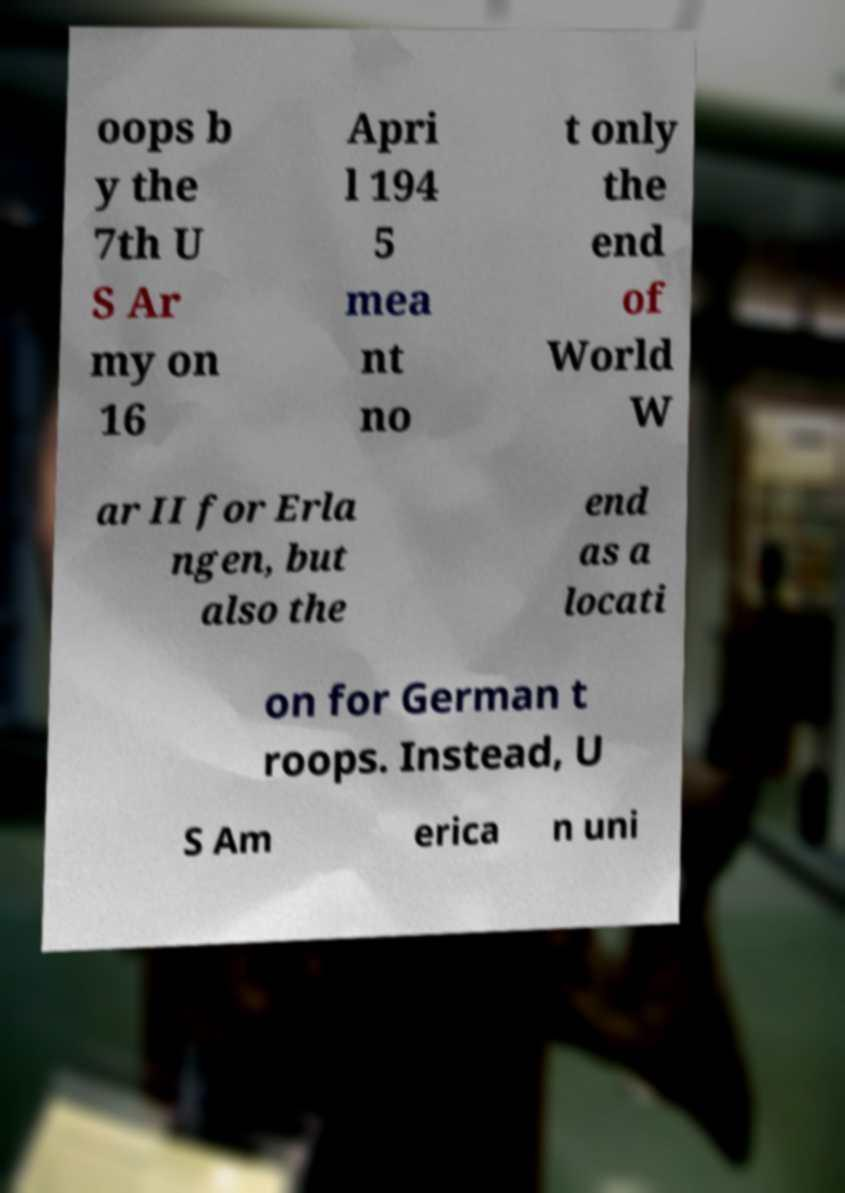Can you read and provide the text displayed in the image?This photo seems to have some interesting text. Can you extract and type it out for me? oops b y the 7th U S Ar my on 16 Apri l 194 5 mea nt no t only the end of World W ar II for Erla ngen, but also the end as a locati on for German t roops. Instead, U S Am erica n uni 